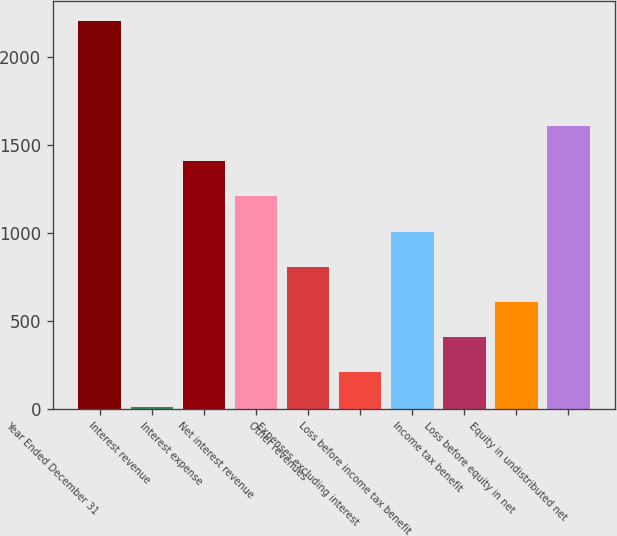Convert chart. <chart><loc_0><loc_0><loc_500><loc_500><bar_chart><fcel>Year Ended December 31<fcel>Interest revenue<fcel>Interest expense<fcel>Net interest revenue<fcel>Other revenues<fcel>Expenses excluding interest<fcel>Loss before income tax benefit<fcel>Income tax benefit<fcel>Loss before equity in net<fcel>Equity in undistributed net<nl><fcel>2209.1<fcel>8<fcel>1408.7<fcel>1208.6<fcel>808.4<fcel>208.1<fcel>1008.5<fcel>408.2<fcel>608.3<fcel>1608.8<nl></chart> 